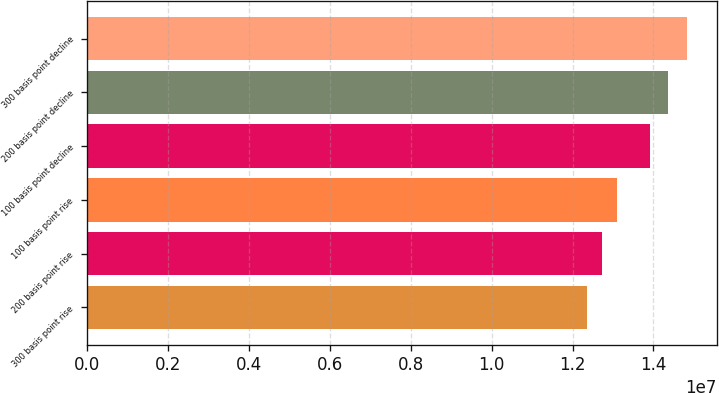Convert chart. <chart><loc_0><loc_0><loc_500><loc_500><bar_chart><fcel>300 basis point rise<fcel>200 basis point rise<fcel>100 basis point rise<fcel>100 basis point decline<fcel>200 basis point decline<fcel>300 basis point decline<nl><fcel>1.23605e+07<fcel>1.27199e+07<fcel>1.31002e+07<fcel>1.39252e+07<fcel>1.43642e+07<fcel>1.48245e+07<nl></chart> 